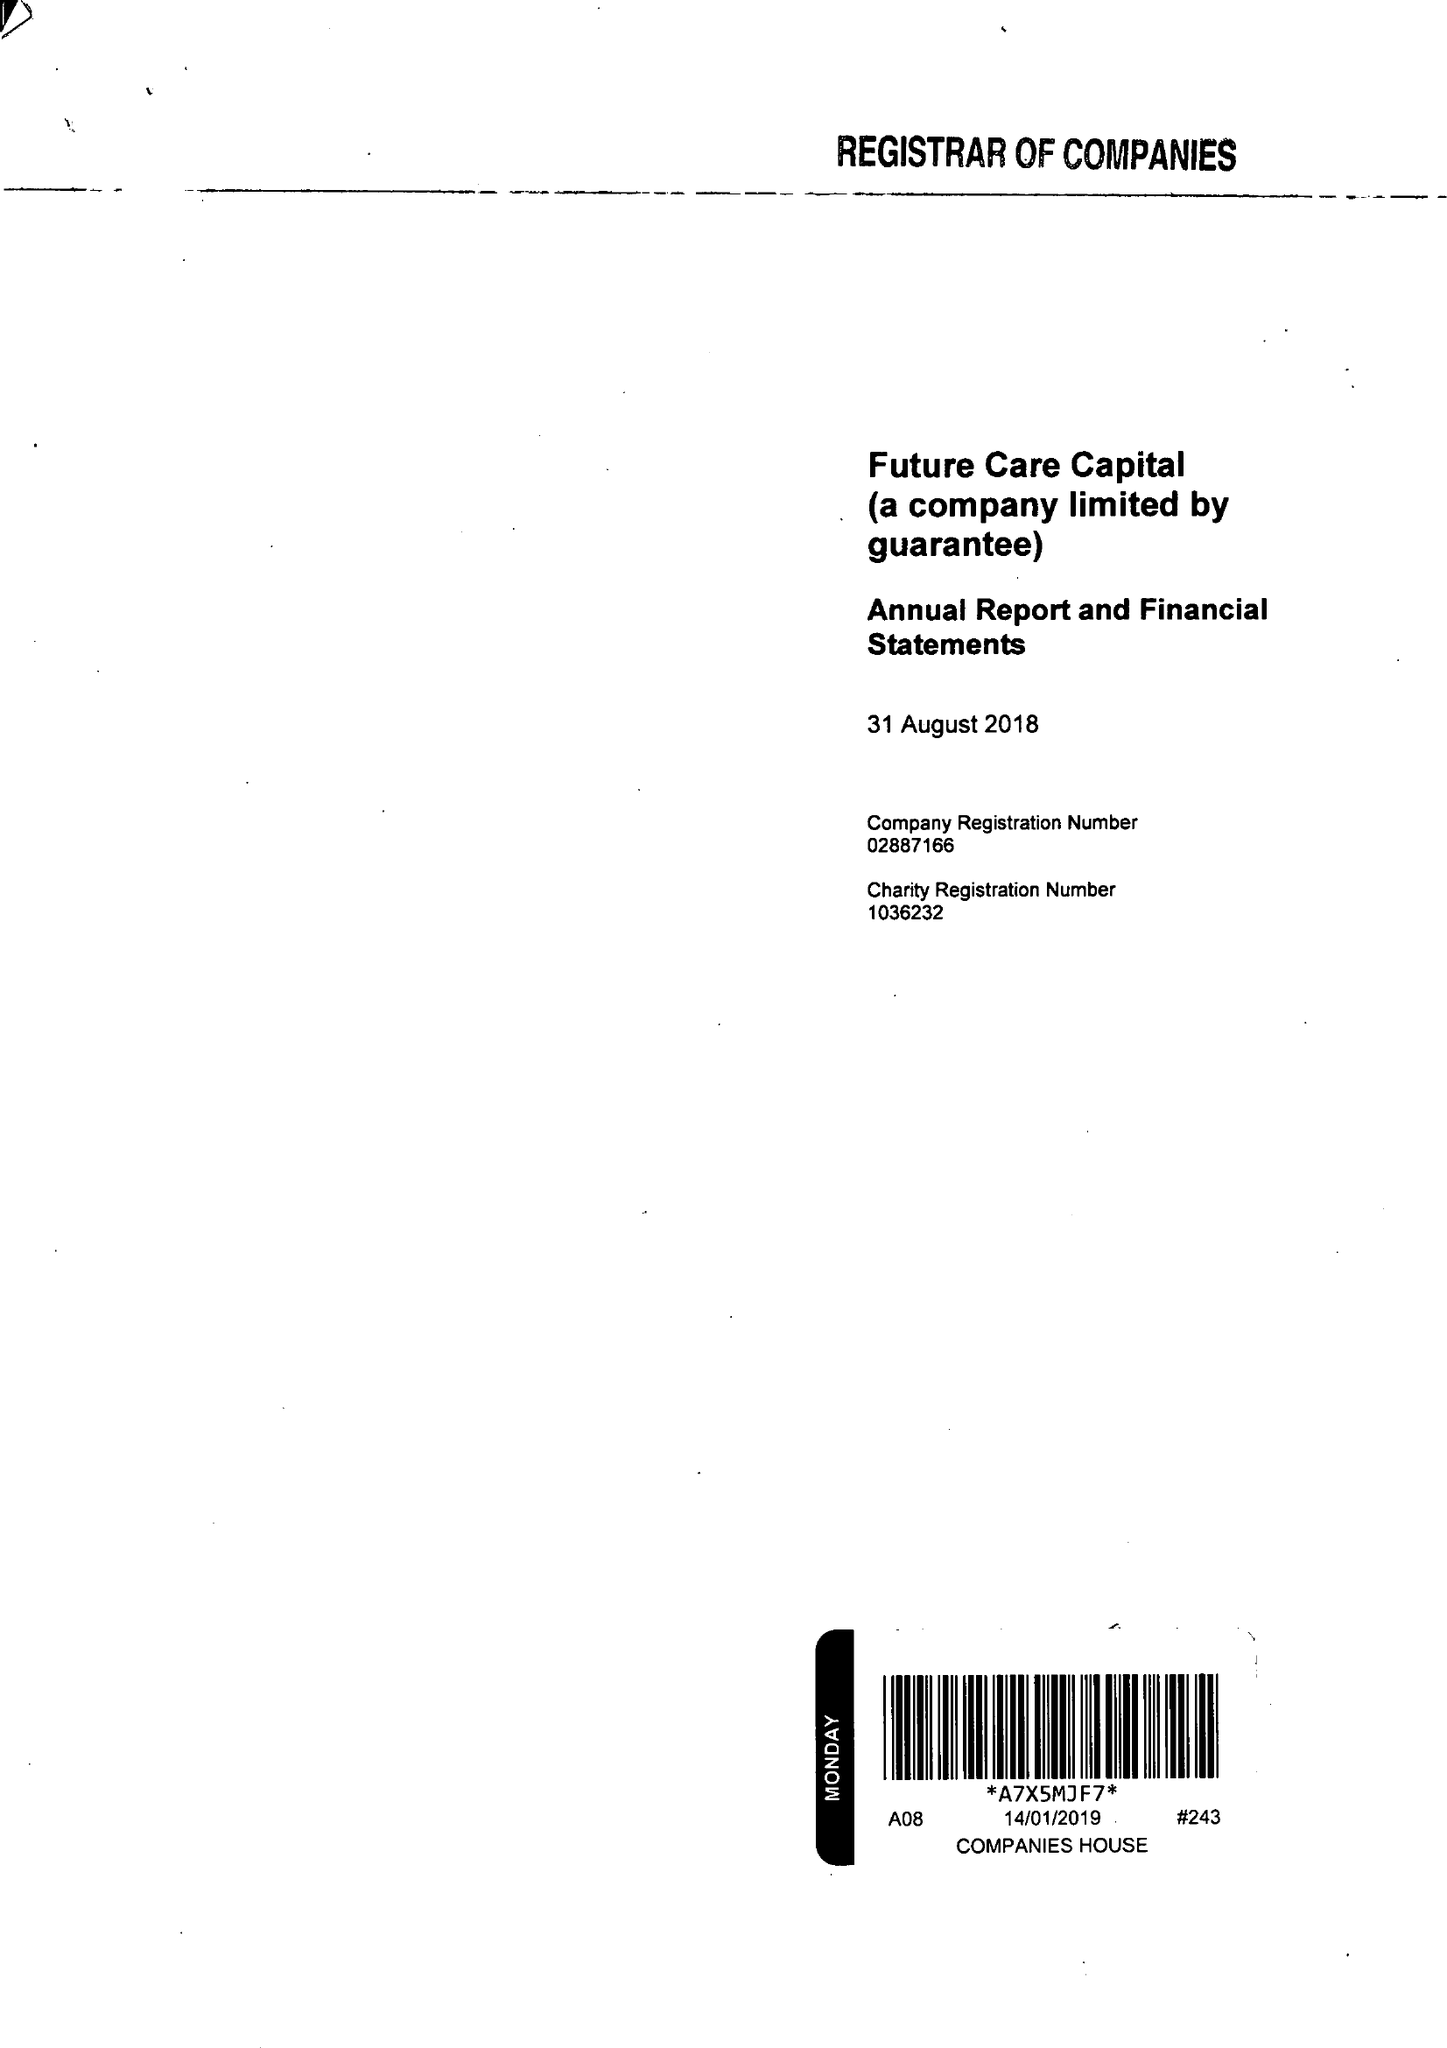What is the value for the income_annually_in_british_pounds?
Answer the question using a single word or phrase. 285000.00 